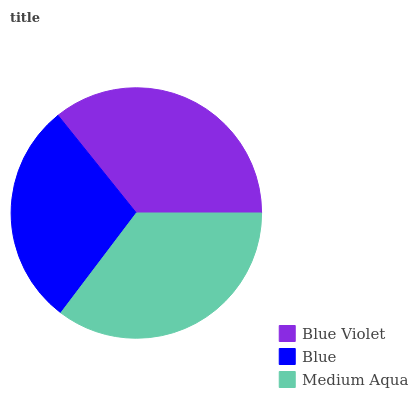Is Blue the minimum?
Answer yes or no. Yes. Is Blue Violet the maximum?
Answer yes or no. Yes. Is Medium Aqua the minimum?
Answer yes or no. No. Is Medium Aqua the maximum?
Answer yes or no. No. Is Medium Aqua greater than Blue?
Answer yes or no. Yes. Is Blue less than Medium Aqua?
Answer yes or no. Yes. Is Blue greater than Medium Aqua?
Answer yes or no. No. Is Medium Aqua less than Blue?
Answer yes or no. No. Is Medium Aqua the high median?
Answer yes or no. Yes. Is Medium Aqua the low median?
Answer yes or no. Yes. Is Blue the high median?
Answer yes or no. No. Is Blue Violet the low median?
Answer yes or no. No. 